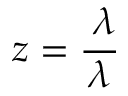<formula> <loc_0><loc_0><loc_500><loc_500>z = \frac { \triangle d o w n \lambda } { \lambda }</formula> 